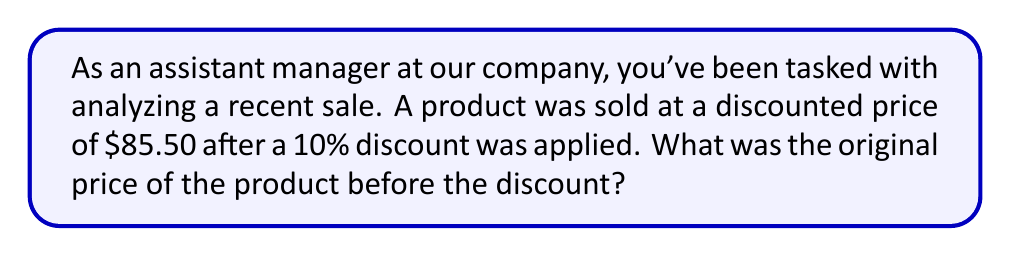Show me your answer to this math problem. Let's approach this step-by-step:

1) Let $x$ be the original price of the product.

2) The discounted price is 90% of the original price (since a 10% discount was applied).

3) We can express this as an equation:
   $$0.90x = 85.50$$

4) To solve for $x$, divide both sides by 0.90:
   $$x = \frac{85.50}{0.90}$$

5) Perform the division:
   $$x = 95$$

6) To verify:
   10% of $95 is $9.50
   $95 - $9.50 = $85.50, which matches the given discounted price.

Therefore, the original price of the product was $95.
Answer: $95 